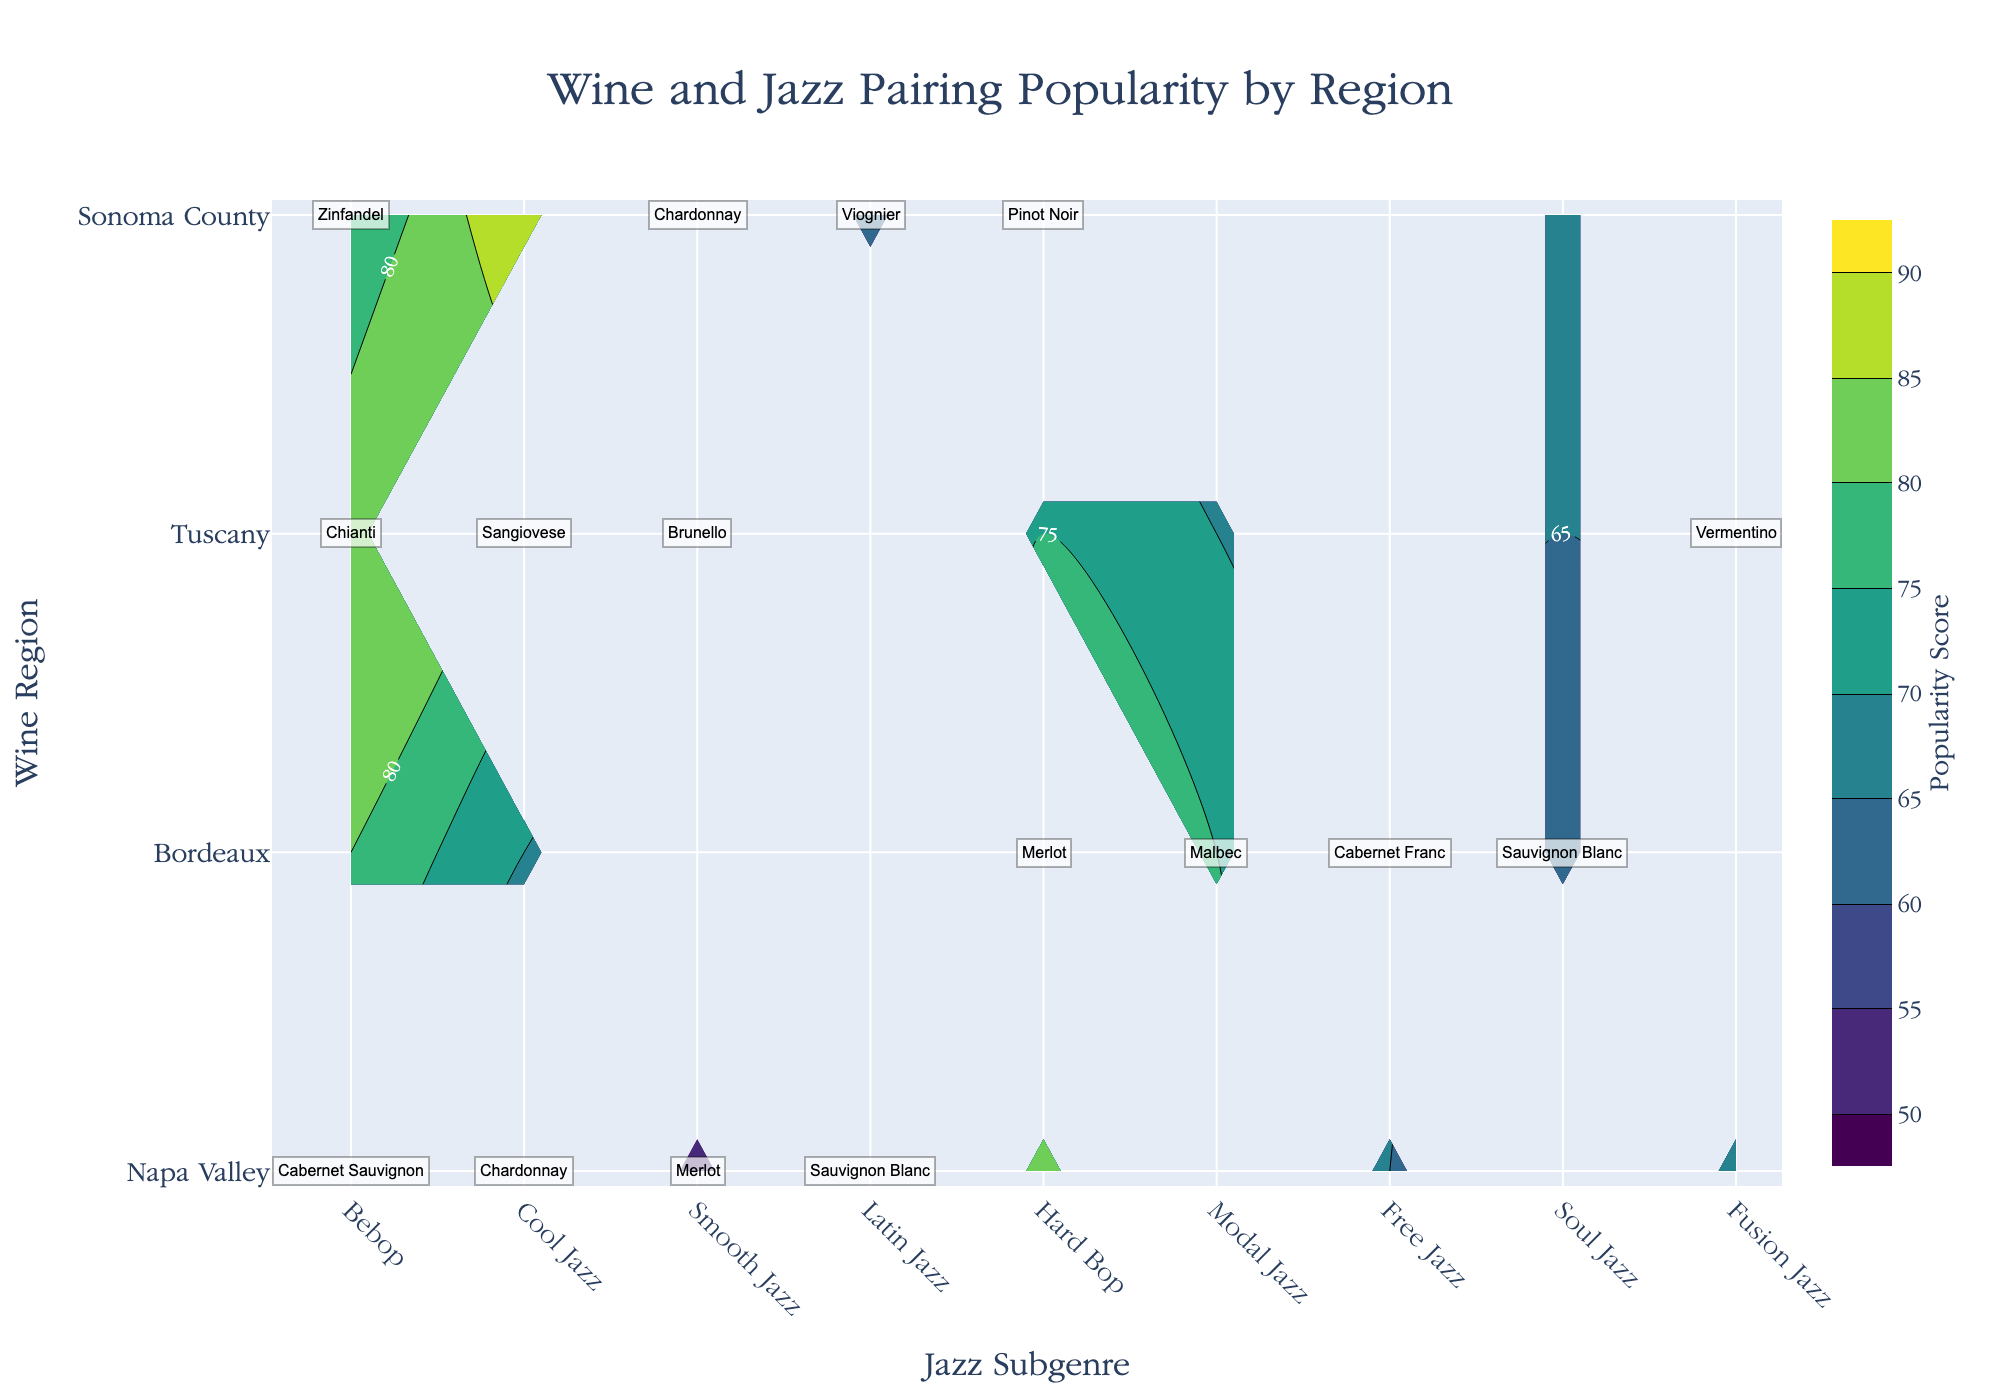What's the title of the figure? The title is prominently displayed at the top center of the figure.
Answer: Wine and Jazz Pairing Popularity by Region How many wine regions are shown in the figure? The y-axis lists all the wine regions included in the data. Count each unique region on the y-axis.
Answer: 4 Which region has the highest popularity score for any jazz subgenre? By examining the contour plot, locate the highest value label, which is found in the region with the highest score.
Answer: Tuscany What's the most popular wine-jazz pairing in Napa Valley? For Napa Valley on the y-axis, find the label with the highest popularity score on the contour plot.
Answer: Cabernet Sauvignon and Bebop Which jazz subgenre pairs with the least popular wine in Bordeaux? For Bordeaux on the y-axis, locate the lowest contour value and note the corresponding jazz subgenre label.
Answer: Free Jazz What's the average popularity score for Bebop across all regions? Sum the popularity scores for Bebop in each region and divide by the number of regions. For Bebop, add 80 (Napa Valley), 75 (Tuscany), and 85 (Sonoma County), then divide by 3.
Answer: 80 Which region has the least popular pair for Smooth Jazz? For Smooth Jazz on the x-axis, identify the region with the lowest contour value.
Answer: Napa Valley How does the popularity of Merlot in Sonoma County compare to that in Bordeaux? Check the contour plots for the labels Merlot in both Sonoma County and Bordeaux, and compare their popularity scores.
Answer: Higher in Bordeaux What wine is paired with Fusion Jazz in Tuscany? Locate Fusion Jazz on the x-axis for Tuscany and read the wine type label.
Answer: Vermentino What are the popularity scores of Latin Jazz in Napa Valley and Smooth Jazz in Bordeaux? Are they equal? Check the contour plot for the scores at the intersection of Latin Jazz in Napa Valley and Smooth Jazz in Bordeaux. Compare the two scores.
Answer: 75 and 70, respectively. No 